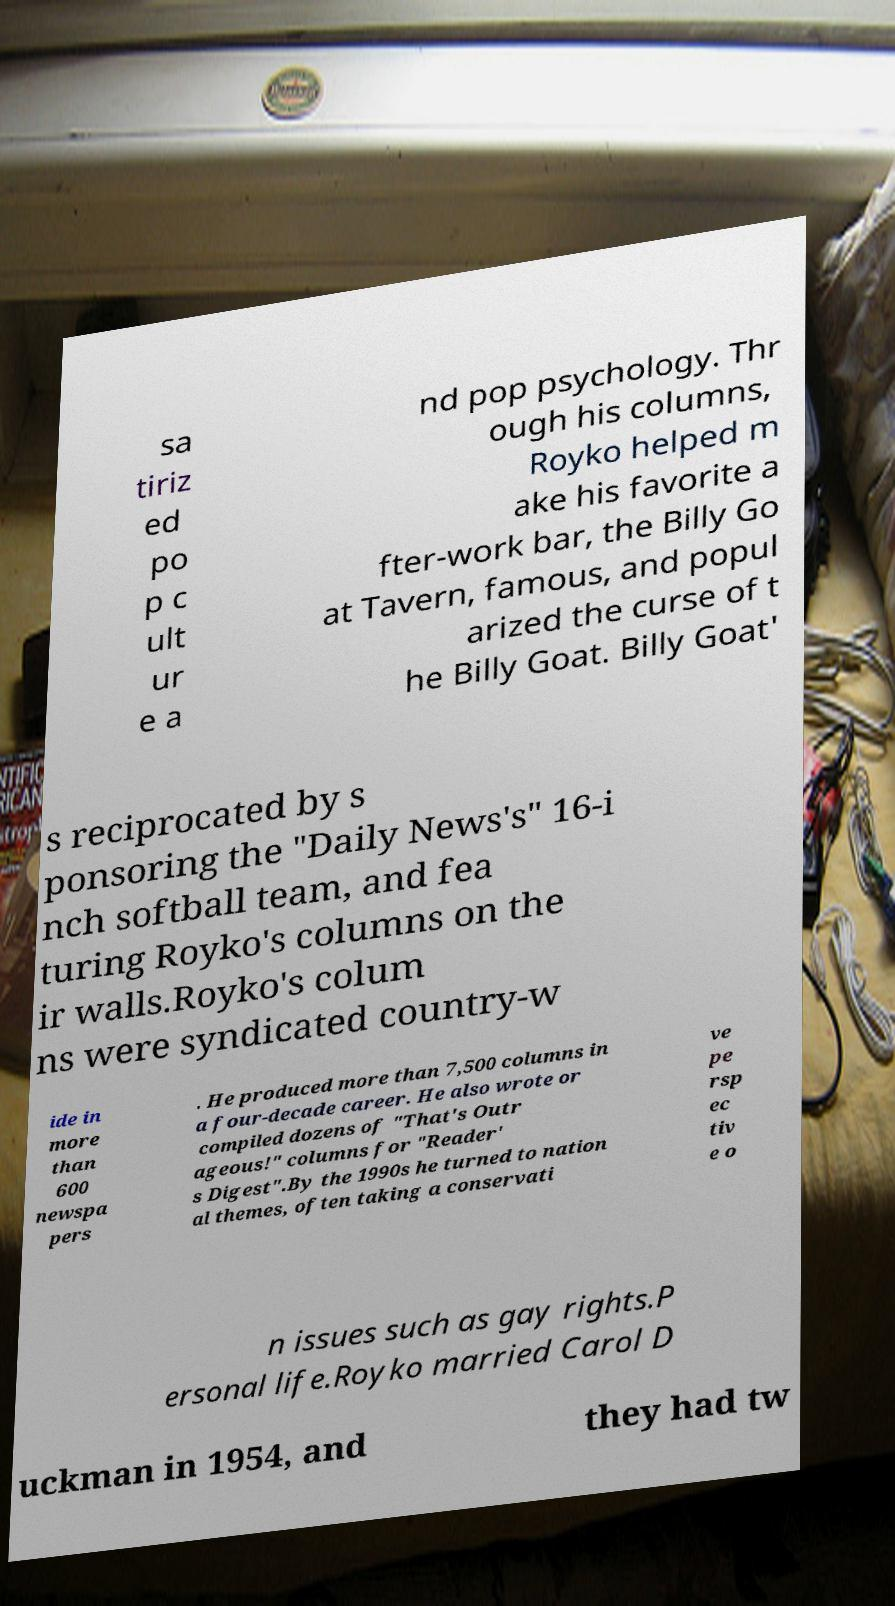Can you accurately transcribe the text from the provided image for me? sa tiriz ed po p c ult ur e a nd pop psychology. Thr ough his columns, Royko helped m ake his favorite a fter-work bar, the Billy Go at Tavern, famous, and popul arized the curse of t he Billy Goat. Billy Goat' s reciprocated by s ponsoring the "Daily News's" 16-i nch softball team, and fea turing Royko's columns on the ir walls.Royko's colum ns were syndicated country-w ide in more than 600 newspa pers . He produced more than 7,500 columns in a four-decade career. He also wrote or compiled dozens of "That's Outr ageous!" columns for "Reader' s Digest".By the 1990s he turned to nation al themes, often taking a conservati ve pe rsp ec tiv e o n issues such as gay rights.P ersonal life.Royko married Carol D uckman in 1954, and they had tw 